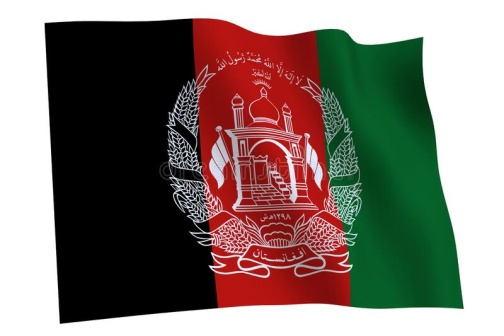Can you tell more about the design elements inside the emblem? The emblem inside the Afghan flag is rich with symbolism. It features a mosque which signifies the Islamic faith. The mihrab in the mosque faces Mecca, illustrating the direction of prayer. Surrounding the mosque are two sheaves of wheat, symbolizing the country's agricultural base and the fertility of its land. These elements not only represent religious devotion but also the economic backbone and cultural heritage of Afghanistan. What is the significance of the Arabic inscription on the flag? The Arabic inscription on the flag is the Shahada, which translates to 'There is no god but Allah, Muhammad is the messenger of Allah.' This is a fundamental Islamic creed, central to the faith of millions in Afghanistan and beyond. It underscores the nation's deep religious roots and the importance of Islam in its national identity. 